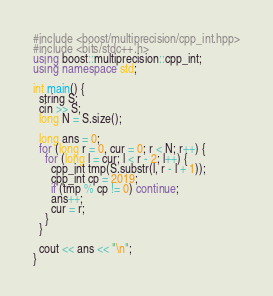Convert code to text. <code><loc_0><loc_0><loc_500><loc_500><_C++_>#include <boost/multiprecision/cpp_int.hpp>
#include <bits/stdc++.h>
using boost::multiprecision::cpp_int;
using namespace std;

int main() {
  string S;
  cin >> S;
  long N = S.size();

  long ans = 0;
  for (long r = 0, cur = 0; r < N; r++) {
    for (long l = cur; l < r - 2; l++) {
      cpp_int tmp(S.substr(l, r - l + 1));
      cpp_int cp = 2019;
      if (tmp % cp != 0) continue;
      ans++;
      cur = r;
    }
  }

  cout << ans << "\n";
}</code> 